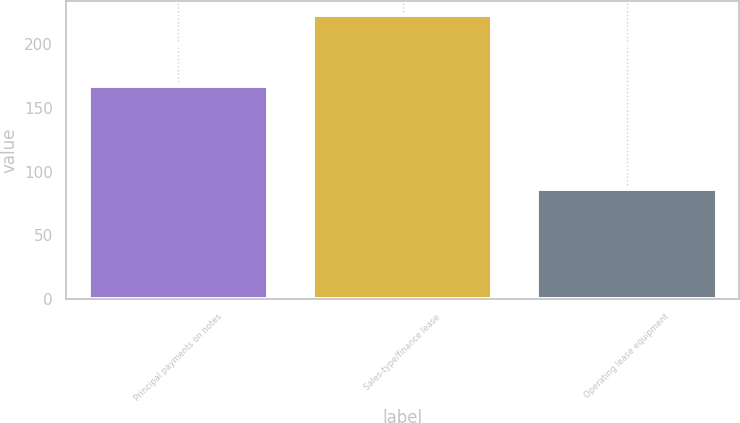Convert chart. <chart><loc_0><loc_0><loc_500><loc_500><bar_chart><fcel>Principal payments on notes<fcel>Sales-type/finance lease<fcel>Operating lease equipment<nl><fcel>167<fcel>223<fcel>86<nl></chart> 